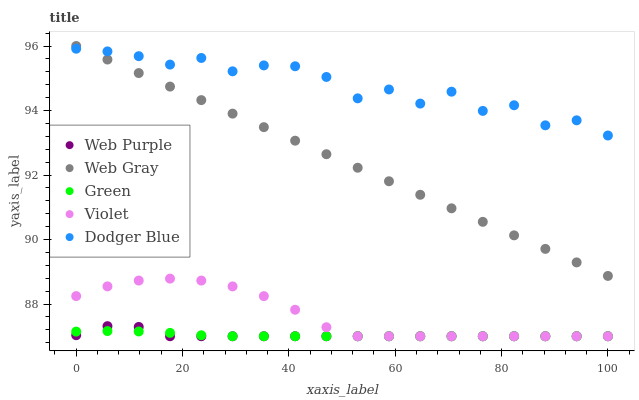Does Green have the minimum area under the curve?
Answer yes or no. Yes. Does Dodger Blue have the maximum area under the curve?
Answer yes or no. Yes. Does Web Purple have the minimum area under the curve?
Answer yes or no. No. Does Web Purple have the maximum area under the curve?
Answer yes or no. No. Is Web Gray the smoothest?
Answer yes or no. Yes. Is Dodger Blue the roughest?
Answer yes or no. Yes. Is Web Purple the smoothest?
Answer yes or no. No. Is Web Purple the roughest?
Answer yes or no. No. Does Web Purple have the lowest value?
Answer yes or no. Yes. Does Web Gray have the lowest value?
Answer yes or no. No. Does Web Gray have the highest value?
Answer yes or no. Yes. Does Web Purple have the highest value?
Answer yes or no. No. Is Web Purple less than Dodger Blue?
Answer yes or no. Yes. Is Web Gray greater than Web Purple?
Answer yes or no. Yes. Does Dodger Blue intersect Web Gray?
Answer yes or no. Yes. Is Dodger Blue less than Web Gray?
Answer yes or no. No. Is Dodger Blue greater than Web Gray?
Answer yes or no. No. Does Web Purple intersect Dodger Blue?
Answer yes or no. No. 